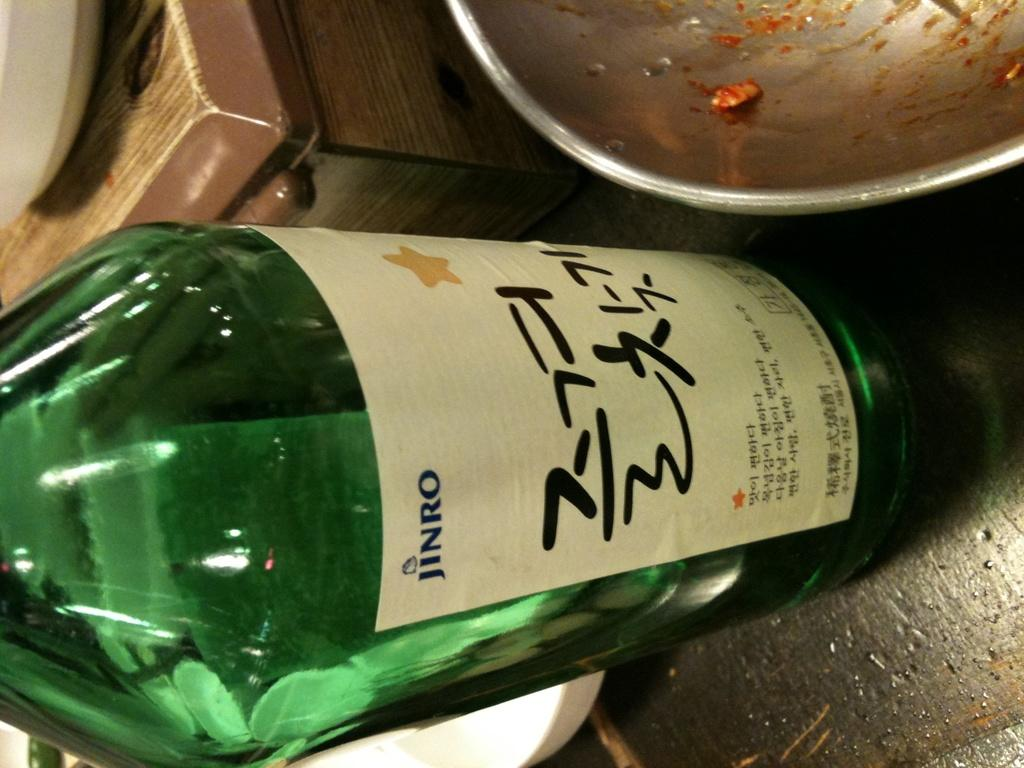Provide a one-sentence caption for the provided image. A bottle of Jinro next to a metal bowl with food residue. 